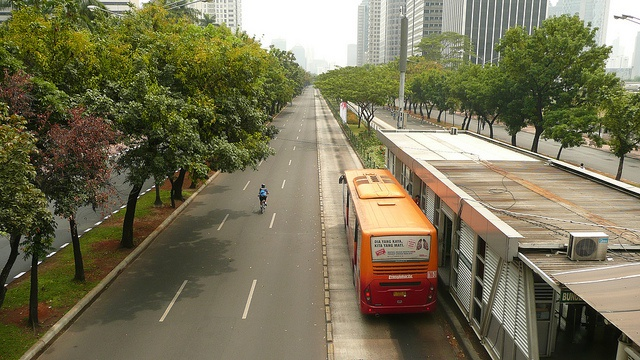Describe the objects in this image and their specific colors. I can see bus in gray, khaki, maroon, black, and orange tones, people in gray, black, and darkgray tones, backpack in gray, black, and lightblue tones, and bicycle in gray, black, and darkgray tones in this image. 